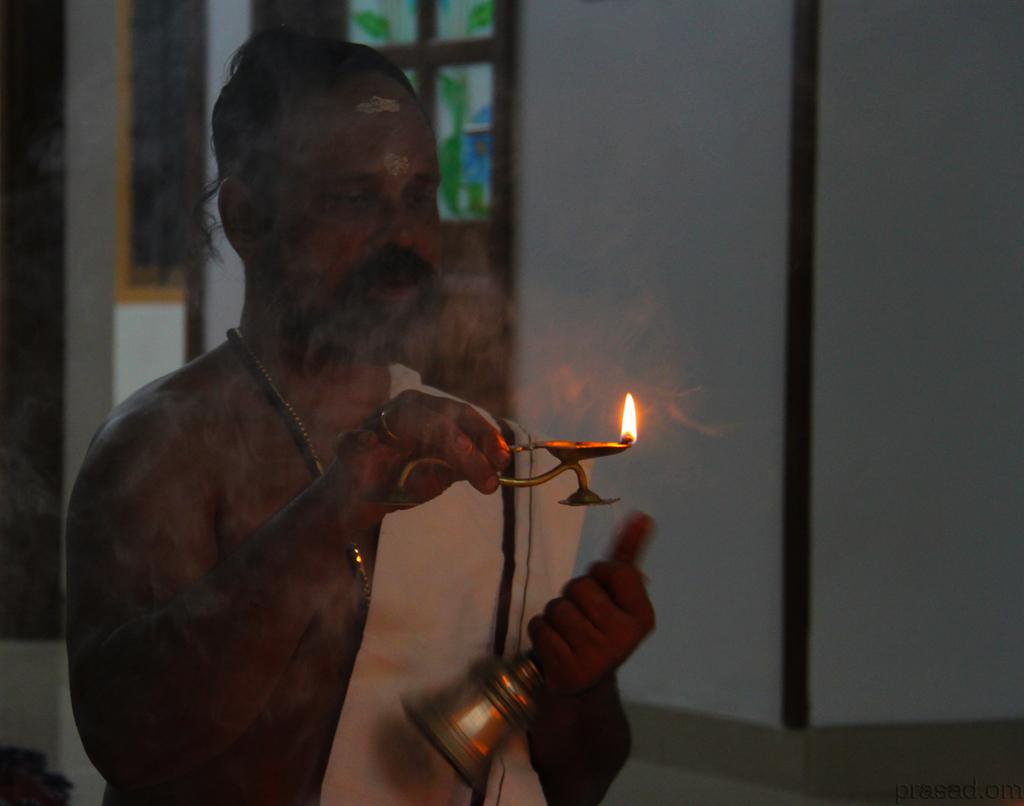What is the person in the image holding? The person in the image is holding a bell. What religious ceremony is depicted in the image? There is an aarthi in the image. What type of structure can be seen in the background? There is a wall in the image. Is there any natural light source visible in the image? Yes, there is a window in the image. How many eggs are present in the image? There are no eggs visible in the image. What type of respect is being shown in the image? The image does not depict a specific type of respect; it shows a person holding a bell and an aarthi. 